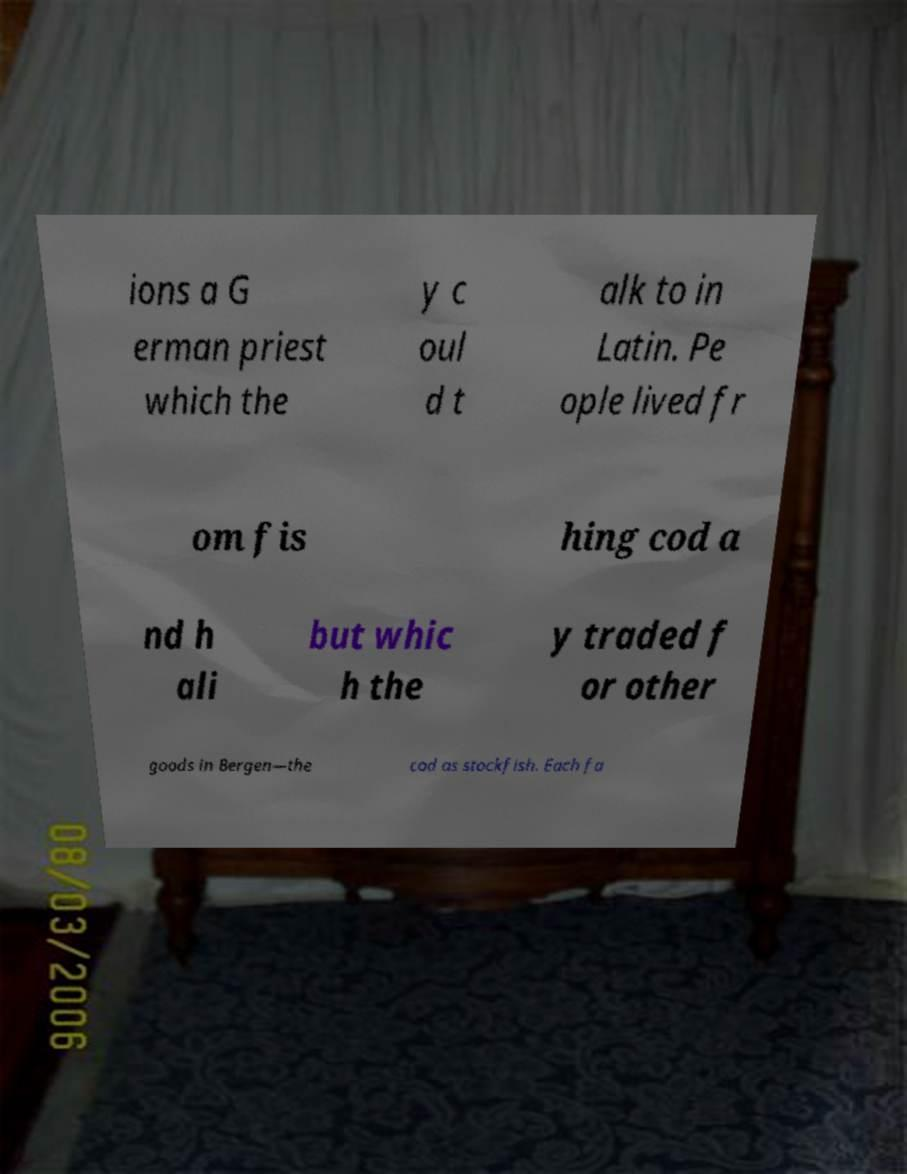Could you assist in decoding the text presented in this image and type it out clearly? ions a G erman priest which the y c oul d t alk to in Latin. Pe ople lived fr om fis hing cod a nd h ali but whic h the y traded f or other goods in Bergen—the cod as stockfish. Each fa 